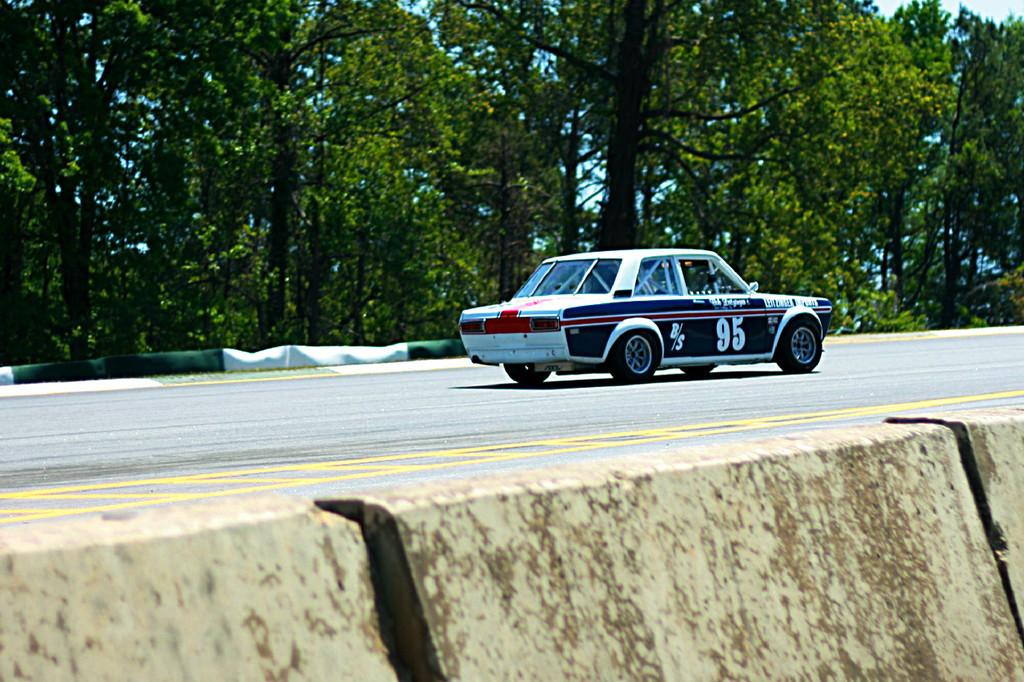What separates the areas in the image? There is a divider in the image. What can be seen on the road in the image? There is a vehicle on the road in the image. What type of natural environment is visible in the background of the image? There are many trees in the background of the image. What is visible above the trees in the image? The sky is visible in the background of the image. What type of power is being generated by the ship in the image? There is no ship present in the image, so the question of power generation is not applicable. 